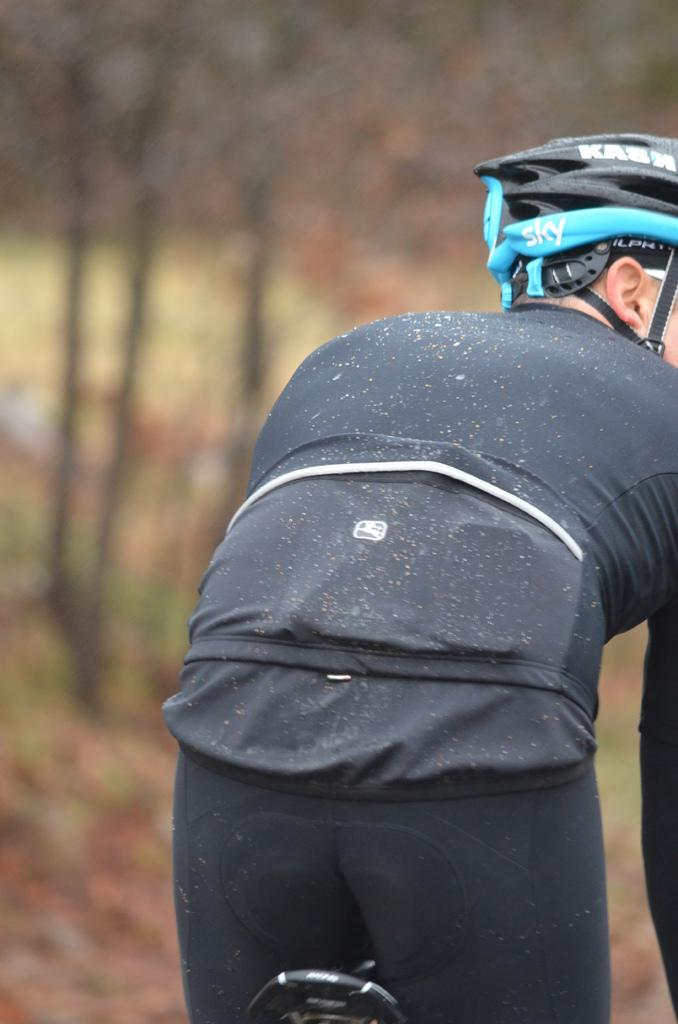Who or what is the main subject in the image? There is a person in the image. What is the person wearing on their head? The person is wearing a headgear. What activity is the person engaged in? The person is riding a bicycle. How many ants can be seen crawling on the person's headgear in the image? There are no ants visible in the image, as the focus is on the person wearing the headgear and riding a bicycle. 